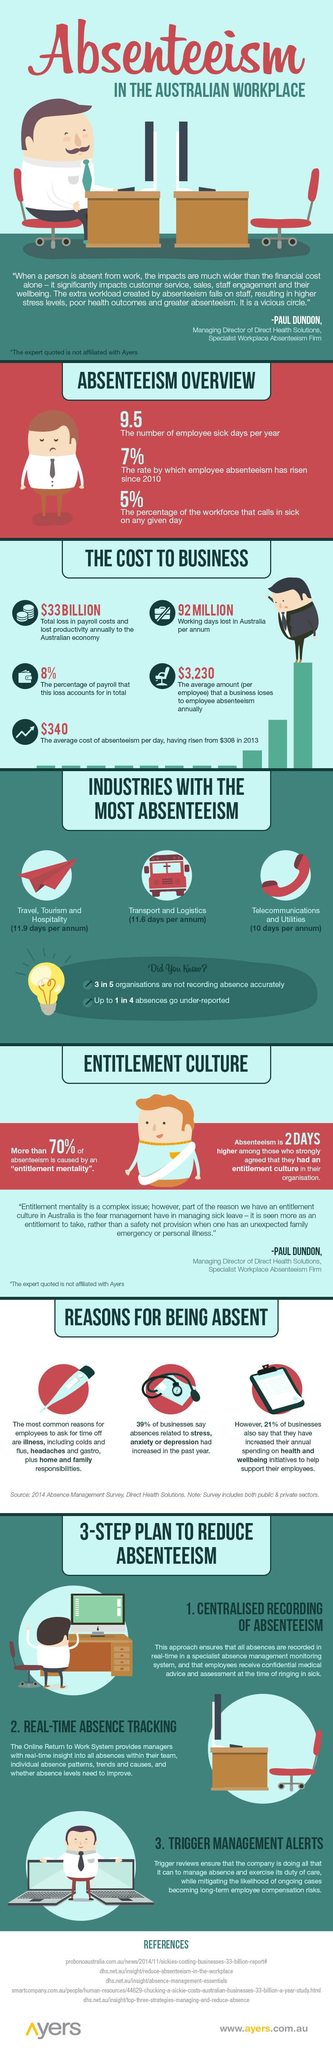Point out several critical features in this image. The plan to reduce absenteeism involves implementing real-time absence tracking as the second step. Travel, Tourism, and Hospitality in Australia experienced the highest levels of absenteeism in the workplace. According to sources, the average amount that a business loses to employee absenteeism annually is estimated to be approximately $3,230. According to the Australian workplace, telecommunications and utilities have the lowest absenteeism rates among all industries. According to the information, 21% of businesses have increased their annual spending on the health and wellbeing of their employees. 